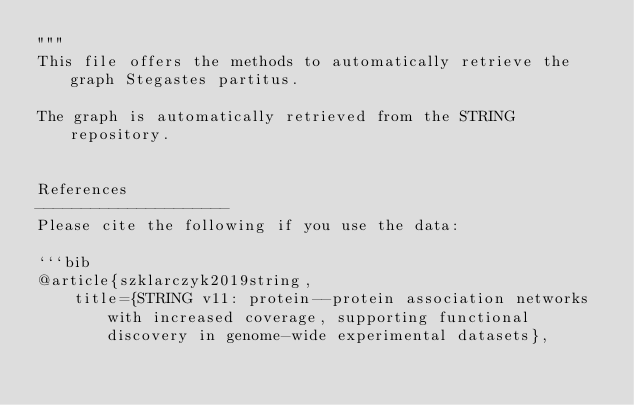Convert code to text. <code><loc_0><loc_0><loc_500><loc_500><_Python_>"""
This file offers the methods to automatically retrieve the graph Stegastes partitus.

The graph is automatically retrieved from the STRING repository. 


References
---------------------
Please cite the following if you use the data:

```bib
@article{szklarczyk2019string,
    title={STRING v11: protein--protein association networks with increased coverage, supporting functional discovery in genome-wide experimental datasets},</code> 